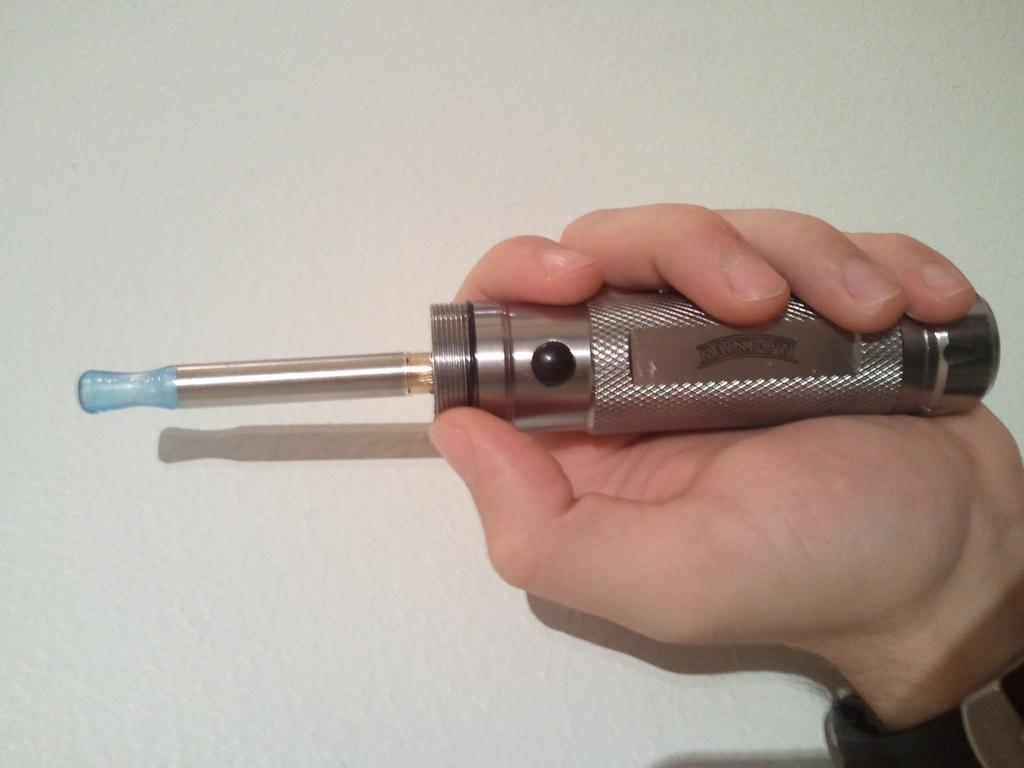What is the main subject of the image? There is a person in the image. What is the person doing in the image? The person is holding an object. What color is the background of the image? The background of the image is white. What type of substance is the person using to cover their face in the image? There is no substance or indication of covering the face in the image; the person is simply holding an object. 